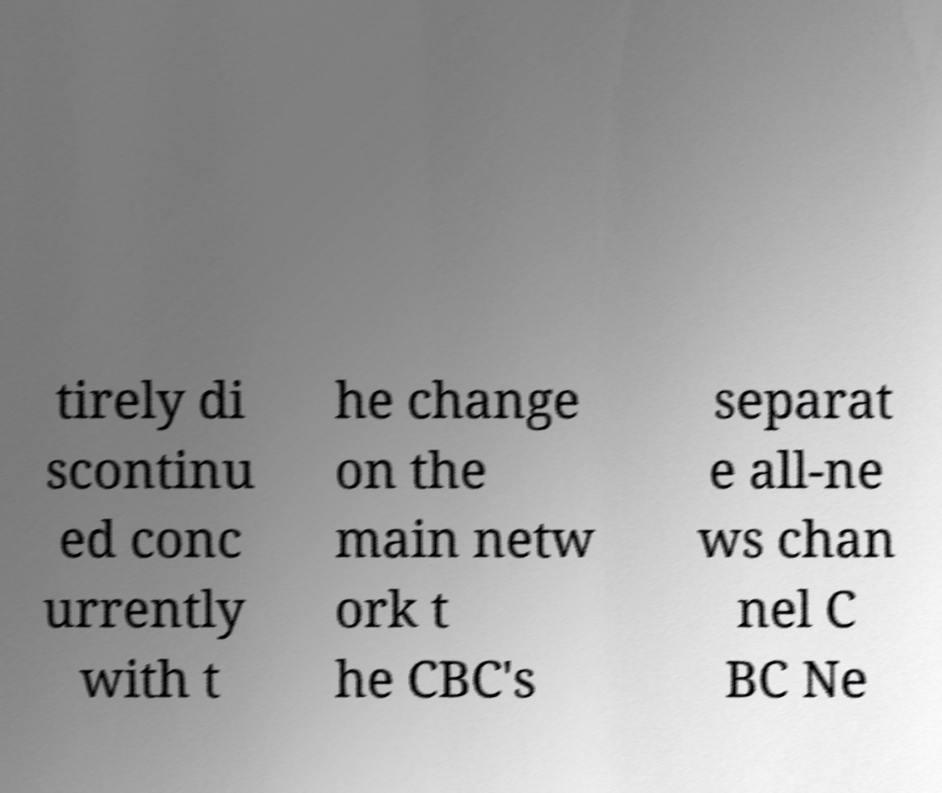Can you read and provide the text displayed in the image?This photo seems to have some interesting text. Can you extract and type it out for me? tirely di scontinu ed conc urrently with t he change on the main netw ork t he CBC's separat e all-ne ws chan nel C BC Ne 